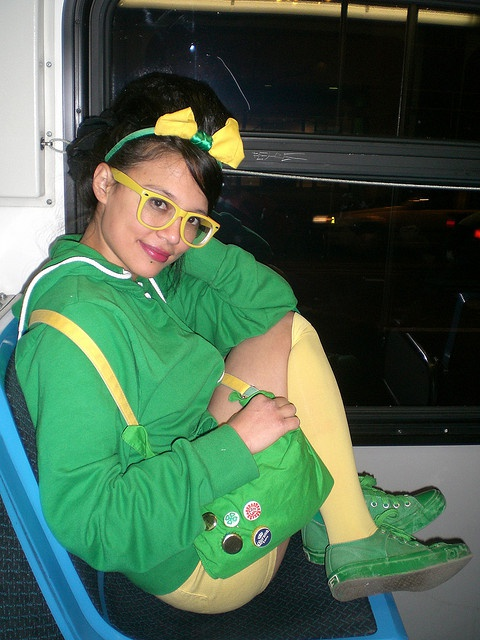Describe the objects in this image and their specific colors. I can see people in darkgray, green, black, and khaki tones and handbag in darkgray, green, lightgreen, and khaki tones in this image. 